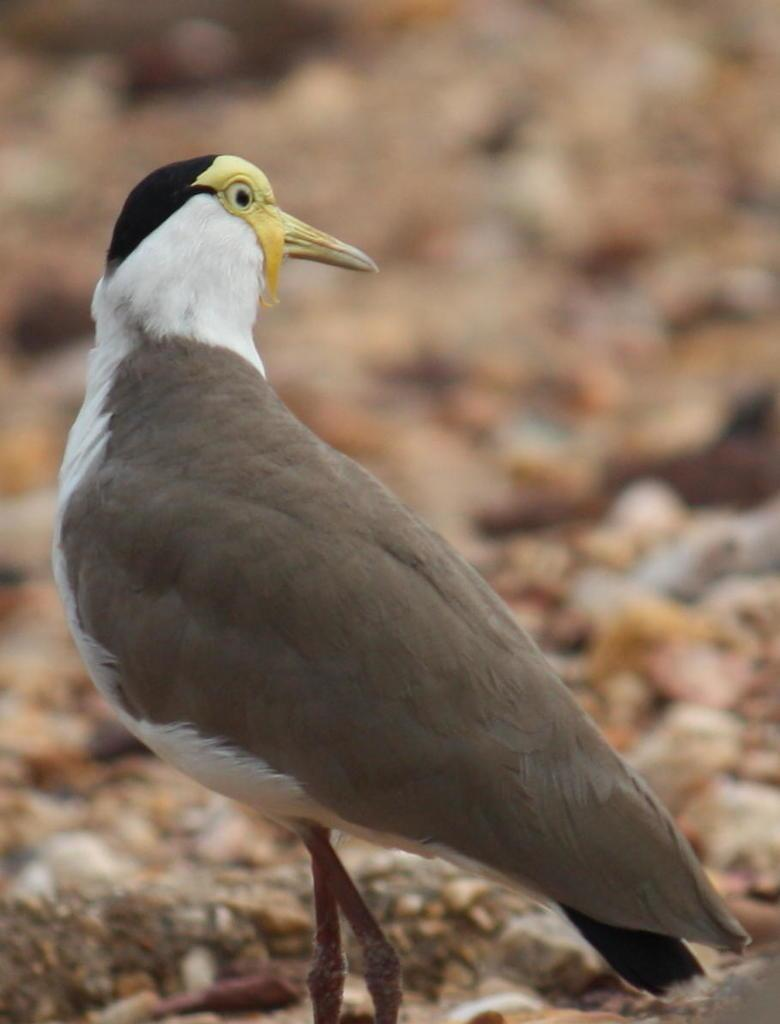What type of animal can be seen in the image? There is a bird in the image. In which direction is the bird looking? The bird is looking to the right side. Can you describe the background of the image? The background of the image is blurred. What type of wax can be seen dripping from the bird's beak in the image? There is no wax present in the image, nor is there any indication that the bird's beak is dripping wax. 